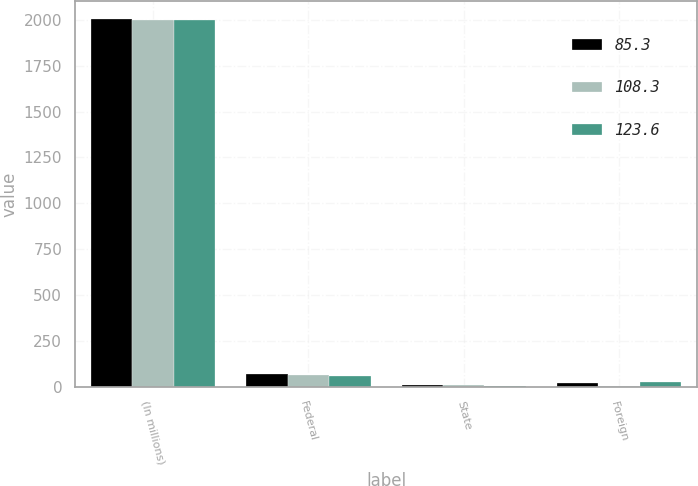<chart> <loc_0><loc_0><loc_500><loc_500><stacked_bar_chart><ecel><fcel>(In millions)<fcel>Federal<fcel>State<fcel>Foreign<nl><fcel>85.3<fcel>2002<fcel>71.9<fcel>10<fcel>20.6<nl><fcel>108.3<fcel>2001<fcel>65.7<fcel>8.4<fcel>5.7<nl><fcel>123.6<fcel>2000<fcel>60.6<fcel>2.9<fcel>25.6<nl></chart> 